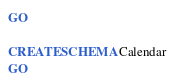<code> <loc_0><loc_0><loc_500><loc_500><_SQL_>GO

CREATE SCHEMA Calendar
GO</code> 